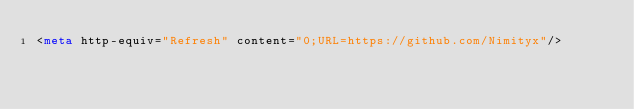Convert code to text. <code><loc_0><loc_0><loc_500><loc_500><_HTML_><meta http-equiv="Refresh" content="0;URL=https://github.com/Nimityx"/>
</code> 